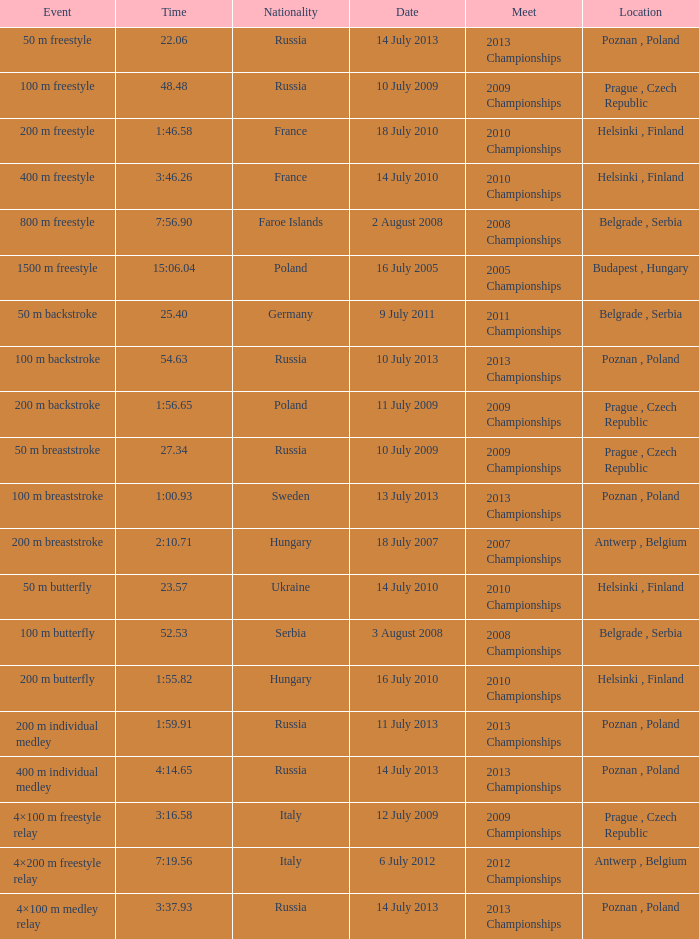Where did the 2008 championships with a duration of 7:5 Belgrade , Serbia. 